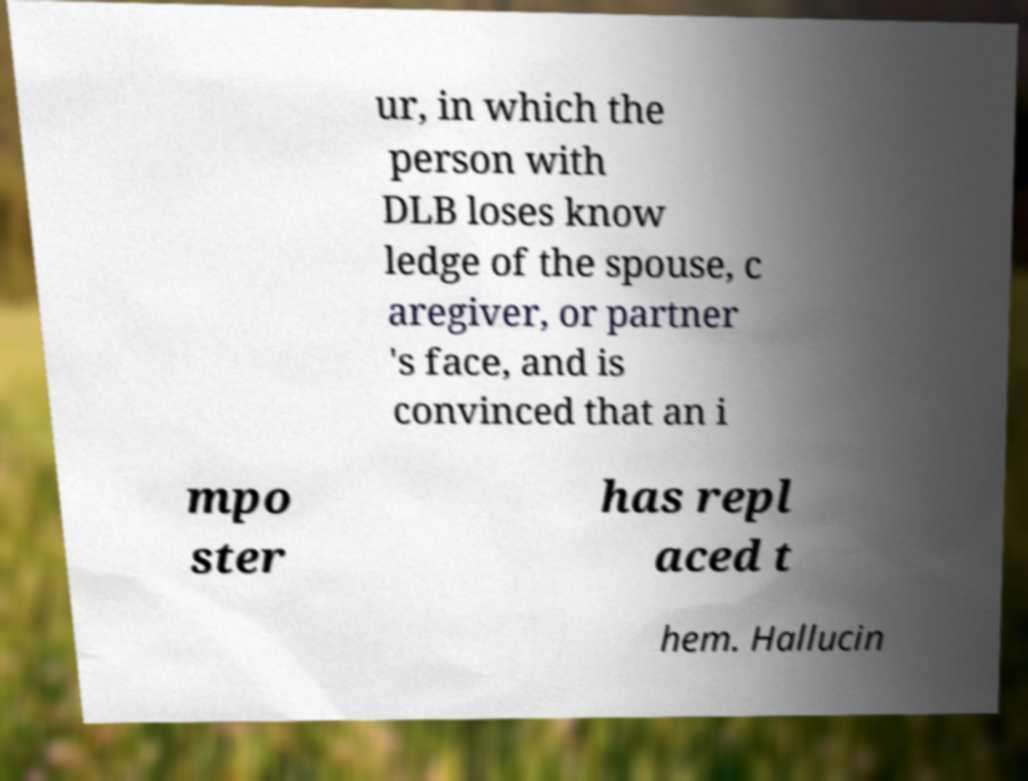Could you extract and type out the text from this image? ur, in which the person with DLB loses know ledge of the spouse, c aregiver, or partner 's face, and is convinced that an i mpo ster has repl aced t hem. Hallucin 